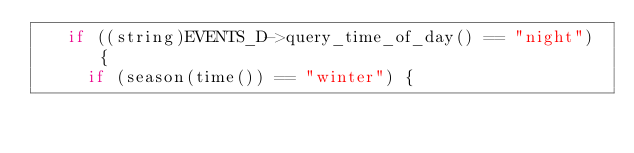<code> <loc_0><loc_0><loc_500><loc_500><_C_>   if ((string)EVENTS_D->query_time_of_day() == "night") {
     if (season(time()) == "winter") {</code> 